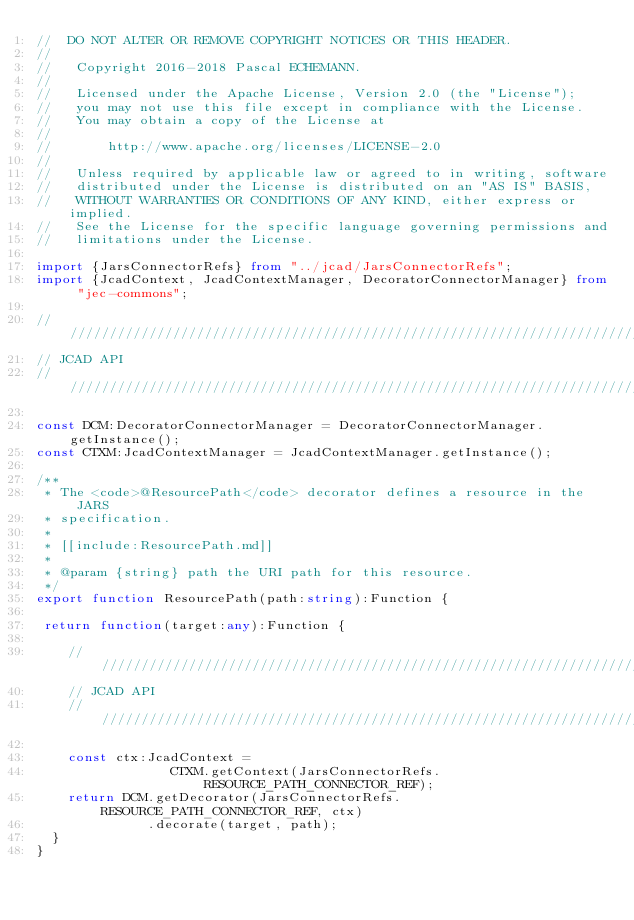<code> <loc_0><loc_0><loc_500><loc_500><_TypeScript_>//  DO NOT ALTER OR REMOVE COPYRIGHT NOTICES OR THIS HEADER.
//
//   Copyright 2016-2018 Pascal ECHEMANN.
//
//   Licensed under the Apache License, Version 2.0 (the "License");
//   you may not use this file except in compliance with the License.
//   You may obtain a copy of the License at
//
//       http://www.apache.org/licenses/LICENSE-2.0
//
//   Unless required by applicable law or agreed to in writing, software
//   distributed under the License is distributed on an "AS IS" BASIS,
//   WITHOUT WARRANTIES OR CONDITIONS OF ANY KIND, either express or implied.
//   See the License for the specific language governing permissions and
//   limitations under the License.

import {JarsConnectorRefs} from "../jcad/JarsConnectorRefs";
import {JcadContext, JcadContextManager, DecoratorConnectorManager} from "jec-commons";

////////////////////////////////////////////////////////////////////////////////
// JCAD API
////////////////////////////////////////////////////////////////////////////////

const DCM:DecoratorConnectorManager = DecoratorConnectorManager.getInstance();
const CTXM:JcadContextManager = JcadContextManager.getInstance();

/**
 * The <code>@ResourcePath</code> decorator defines a resource in the JARS
 * specification.
 *
 * [[include:ResourcePath.md]]
 * 
 * @param {string} path the URI path for this resource.
 */
export function ResourcePath(path:string):Function {

 return function(target:any):Function {
    
    ////////////////////////////////////////////////////////////////////////////
    // JCAD API
    ////////////////////////////////////////////////////////////////////////////

    const ctx:JcadContext =
                 CTXM.getContext(JarsConnectorRefs.RESOURCE_PATH_CONNECTOR_REF);
    return DCM.getDecorator(JarsConnectorRefs.RESOURCE_PATH_CONNECTOR_REF, ctx)
              .decorate(target, path);
  }
}
</code> 